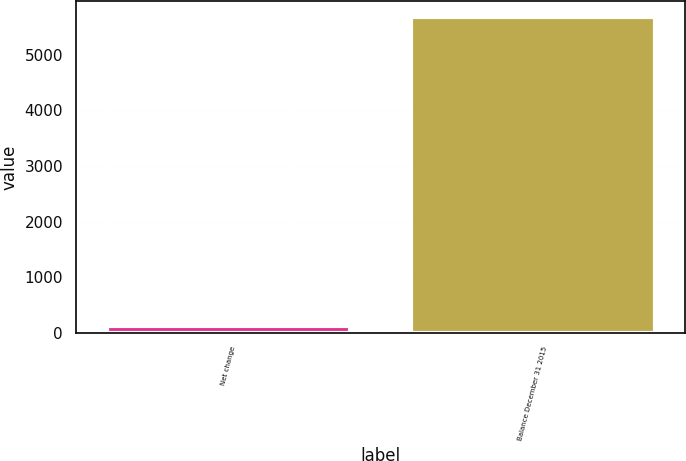Convert chart to OTSL. <chart><loc_0><loc_0><loc_500><loc_500><bar_chart><fcel>Net change<fcel>Balance December 31 2015<nl><fcel>128<fcel>5674<nl></chart> 